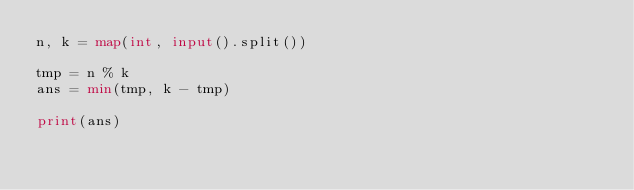Convert code to text. <code><loc_0><loc_0><loc_500><loc_500><_Python_>n, k = map(int, input().split())

tmp = n % k
ans = min(tmp, k - tmp)

print(ans)</code> 